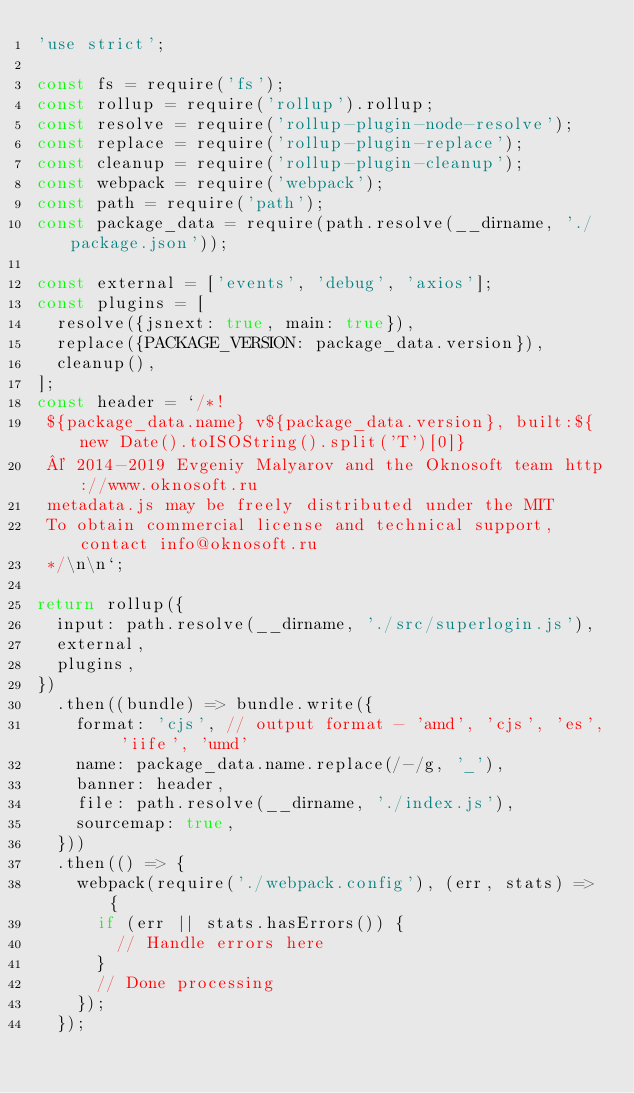Convert code to text. <code><loc_0><loc_0><loc_500><loc_500><_JavaScript_>'use strict';

const fs = require('fs');
const rollup = require('rollup').rollup;
const resolve = require('rollup-plugin-node-resolve');
const replace = require('rollup-plugin-replace');
const cleanup = require('rollup-plugin-cleanup');
const webpack = require('webpack');
const path = require('path');
const package_data = require(path.resolve(__dirname, './package.json'));

const external = ['events', 'debug', 'axios'];
const plugins = [
  resolve({jsnext: true, main: true}),
  replace({PACKAGE_VERSION: package_data.version}),
  cleanup(),
];
const header = `/*!
 ${package_data.name} v${package_data.version}, built:${new Date().toISOString().split('T')[0]}
 © 2014-2019 Evgeniy Malyarov and the Oknosoft team http://www.oknosoft.ru
 metadata.js may be freely distributed under the MIT
 To obtain commercial license and technical support, contact info@oknosoft.ru
 */\n\n`;

return rollup({
  input: path.resolve(__dirname, './src/superlogin.js'),
  external,
  plugins,
})
  .then((bundle) => bundle.write({
    format: 'cjs', // output format - 'amd', 'cjs', 'es', 'iife', 'umd'
    name: package_data.name.replace(/-/g, '_'),
    banner: header,
    file: path.resolve(__dirname, './index.js'),
    sourcemap: true,
  }))
  .then(() => {
    webpack(require('./webpack.config'), (err, stats) => {
      if (err || stats.hasErrors()) {
        // Handle errors here
      }
      // Done processing
    });
  });

</code> 